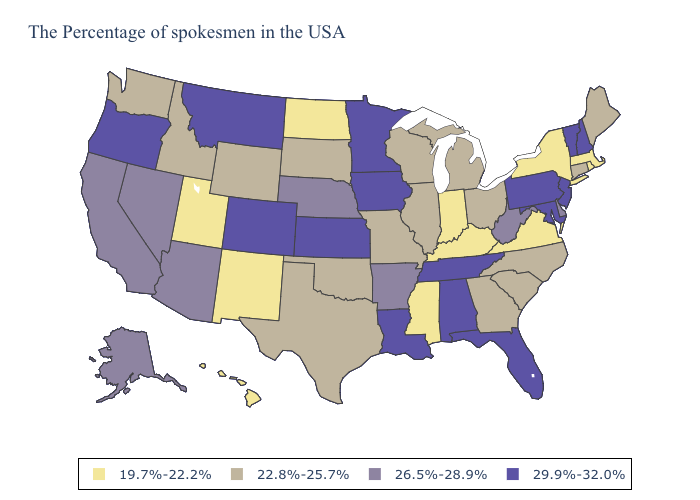What is the value of Iowa?
Be succinct. 29.9%-32.0%. Name the states that have a value in the range 29.9%-32.0%?
Concise answer only. New Hampshire, Vermont, New Jersey, Maryland, Pennsylvania, Florida, Alabama, Tennessee, Louisiana, Minnesota, Iowa, Kansas, Colorado, Montana, Oregon. Name the states that have a value in the range 19.7%-22.2%?
Quick response, please. Massachusetts, Rhode Island, New York, Virginia, Kentucky, Indiana, Mississippi, North Dakota, New Mexico, Utah, Hawaii. What is the lowest value in states that border Tennessee?
Keep it brief. 19.7%-22.2%. Among the states that border New Mexico , does Utah have the lowest value?
Give a very brief answer. Yes. Does the first symbol in the legend represent the smallest category?
Concise answer only. Yes. Name the states that have a value in the range 22.8%-25.7%?
Write a very short answer. Maine, Connecticut, North Carolina, South Carolina, Ohio, Georgia, Michigan, Wisconsin, Illinois, Missouri, Oklahoma, Texas, South Dakota, Wyoming, Idaho, Washington. Does Nevada have a higher value than Hawaii?
Be succinct. Yes. What is the highest value in the USA?
Give a very brief answer. 29.9%-32.0%. What is the value of New Jersey?
Be succinct. 29.9%-32.0%. Name the states that have a value in the range 29.9%-32.0%?
Write a very short answer. New Hampshire, Vermont, New Jersey, Maryland, Pennsylvania, Florida, Alabama, Tennessee, Louisiana, Minnesota, Iowa, Kansas, Colorado, Montana, Oregon. Does the map have missing data?
Give a very brief answer. No. What is the value of West Virginia?
Answer briefly. 26.5%-28.9%. What is the value of Tennessee?
Keep it brief. 29.9%-32.0%. Does the map have missing data?
Give a very brief answer. No. 